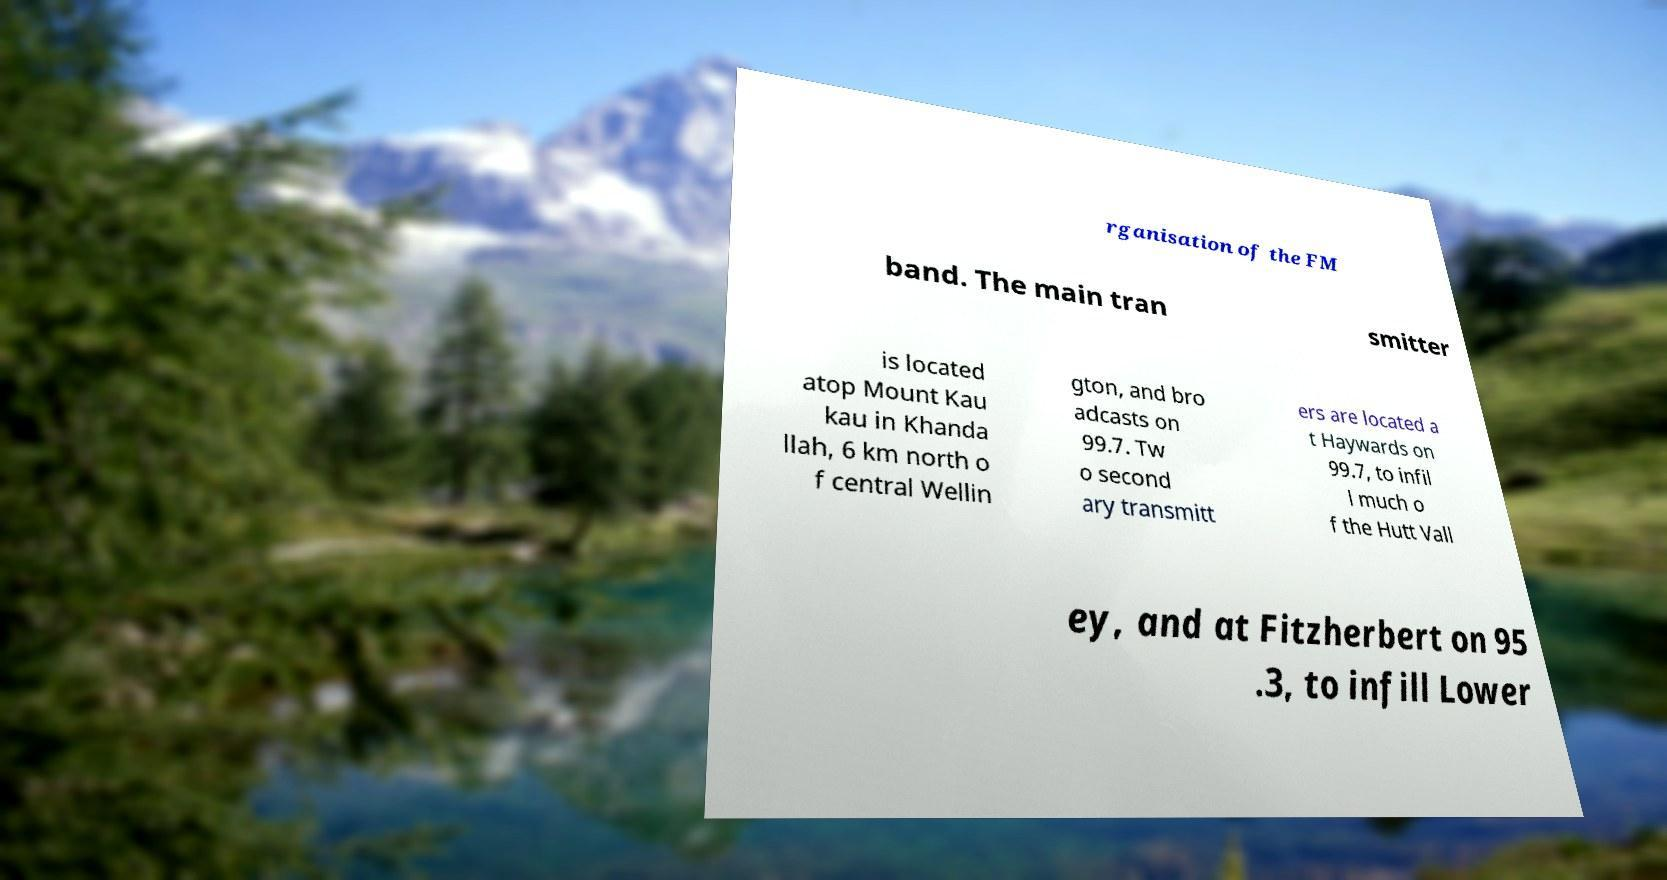Please read and relay the text visible in this image. What does it say? rganisation of the FM band. The main tran smitter is located atop Mount Kau kau in Khanda llah, 6 km north o f central Wellin gton, and bro adcasts on 99.7. Tw o second ary transmitt ers are located a t Haywards on 99.7, to infil l much o f the Hutt Vall ey, and at Fitzherbert on 95 .3, to infill Lower 